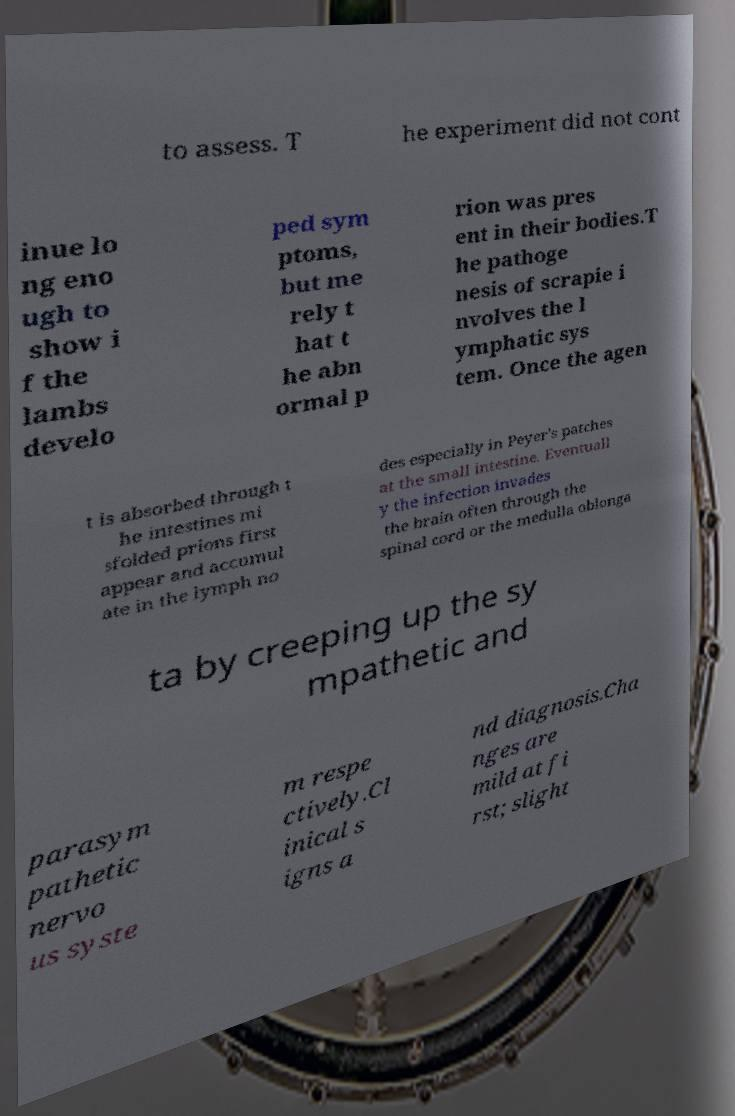Please read and relay the text visible in this image. What does it say? to assess. T he experiment did not cont inue lo ng eno ugh to show i f the lambs develo ped sym ptoms, but me rely t hat t he abn ormal p rion was pres ent in their bodies.T he pathoge nesis of scrapie i nvolves the l ymphatic sys tem. Once the agen t is absorbed through t he intestines mi sfolded prions first appear and accumul ate in the lymph no des especially in Peyer's patches at the small intestine. Eventuall y the infection invades the brain often through the spinal cord or the medulla oblonga ta by creeping up the sy mpathetic and parasym pathetic nervo us syste m respe ctively.Cl inical s igns a nd diagnosis.Cha nges are mild at fi rst; slight 